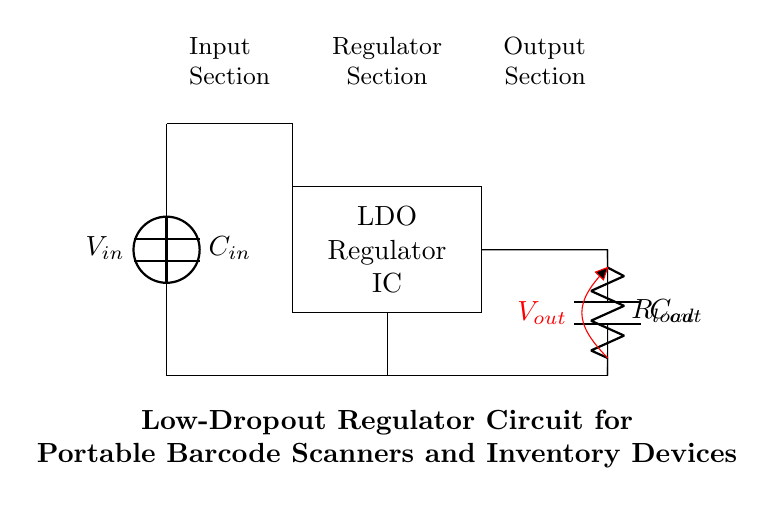What is the input voltage for this circuit? The input voltage is labeled as V_in, which is represented by the voltage source at the top left of the circuit diagram. Since the circuit doesn’t specify a value, we just identify it as V_in.
Answer: V_in What component is indicated in the middle of the circuit? The component in the middle is a rectangle that identifies the Low-Dropout Regulator, labeled as LDO Regulator IC. It is drawn centrally, connecting the input and the output sections of the circuit.
Answer: LDO Regulator IC What is the function of the capacitor C_in? The capacitor C_in is placed between the input voltage and ground, and its main function is to stabilize the input voltage by smoothing out fluctuations, allowing for a more consistent voltage supply to the LDO.
Answer: Stabilizing input voltage What type of load is shown in the output? The output shows a resistor labeled as R_load, which represents the load that the circuit will drive, indicating a typical resistive load for devices such as barcode scanners.
Answer: Resistor Why is it called a low-dropout regulator? A low-dropout regulator is designed to maintain a stable output voltage, even if the input voltage is only slightly above the output voltage, hence the term "low-dropout." This characteristic is particularly useful in battery-operated devices where efficiency is critical.
Answer: Maintains voltage with low difference What is the purpose of the output capacitor C_out? The output capacitor C_out is connected at the output to improve stability and response during transient load changes, ensuring that the output voltage remains steady despite sudden demands from the load.
Answer: Improve stability and response What happens if the input voltage drops below the output voltage? If the input voltage drops below the output voltage in a low-dropout regulator, it can no longer provide the required output voltage, leading to a state where the output cannot meet the demands of the load, which can result in voltage sag or failure in operation.
Answer: Output fails to meet demands 